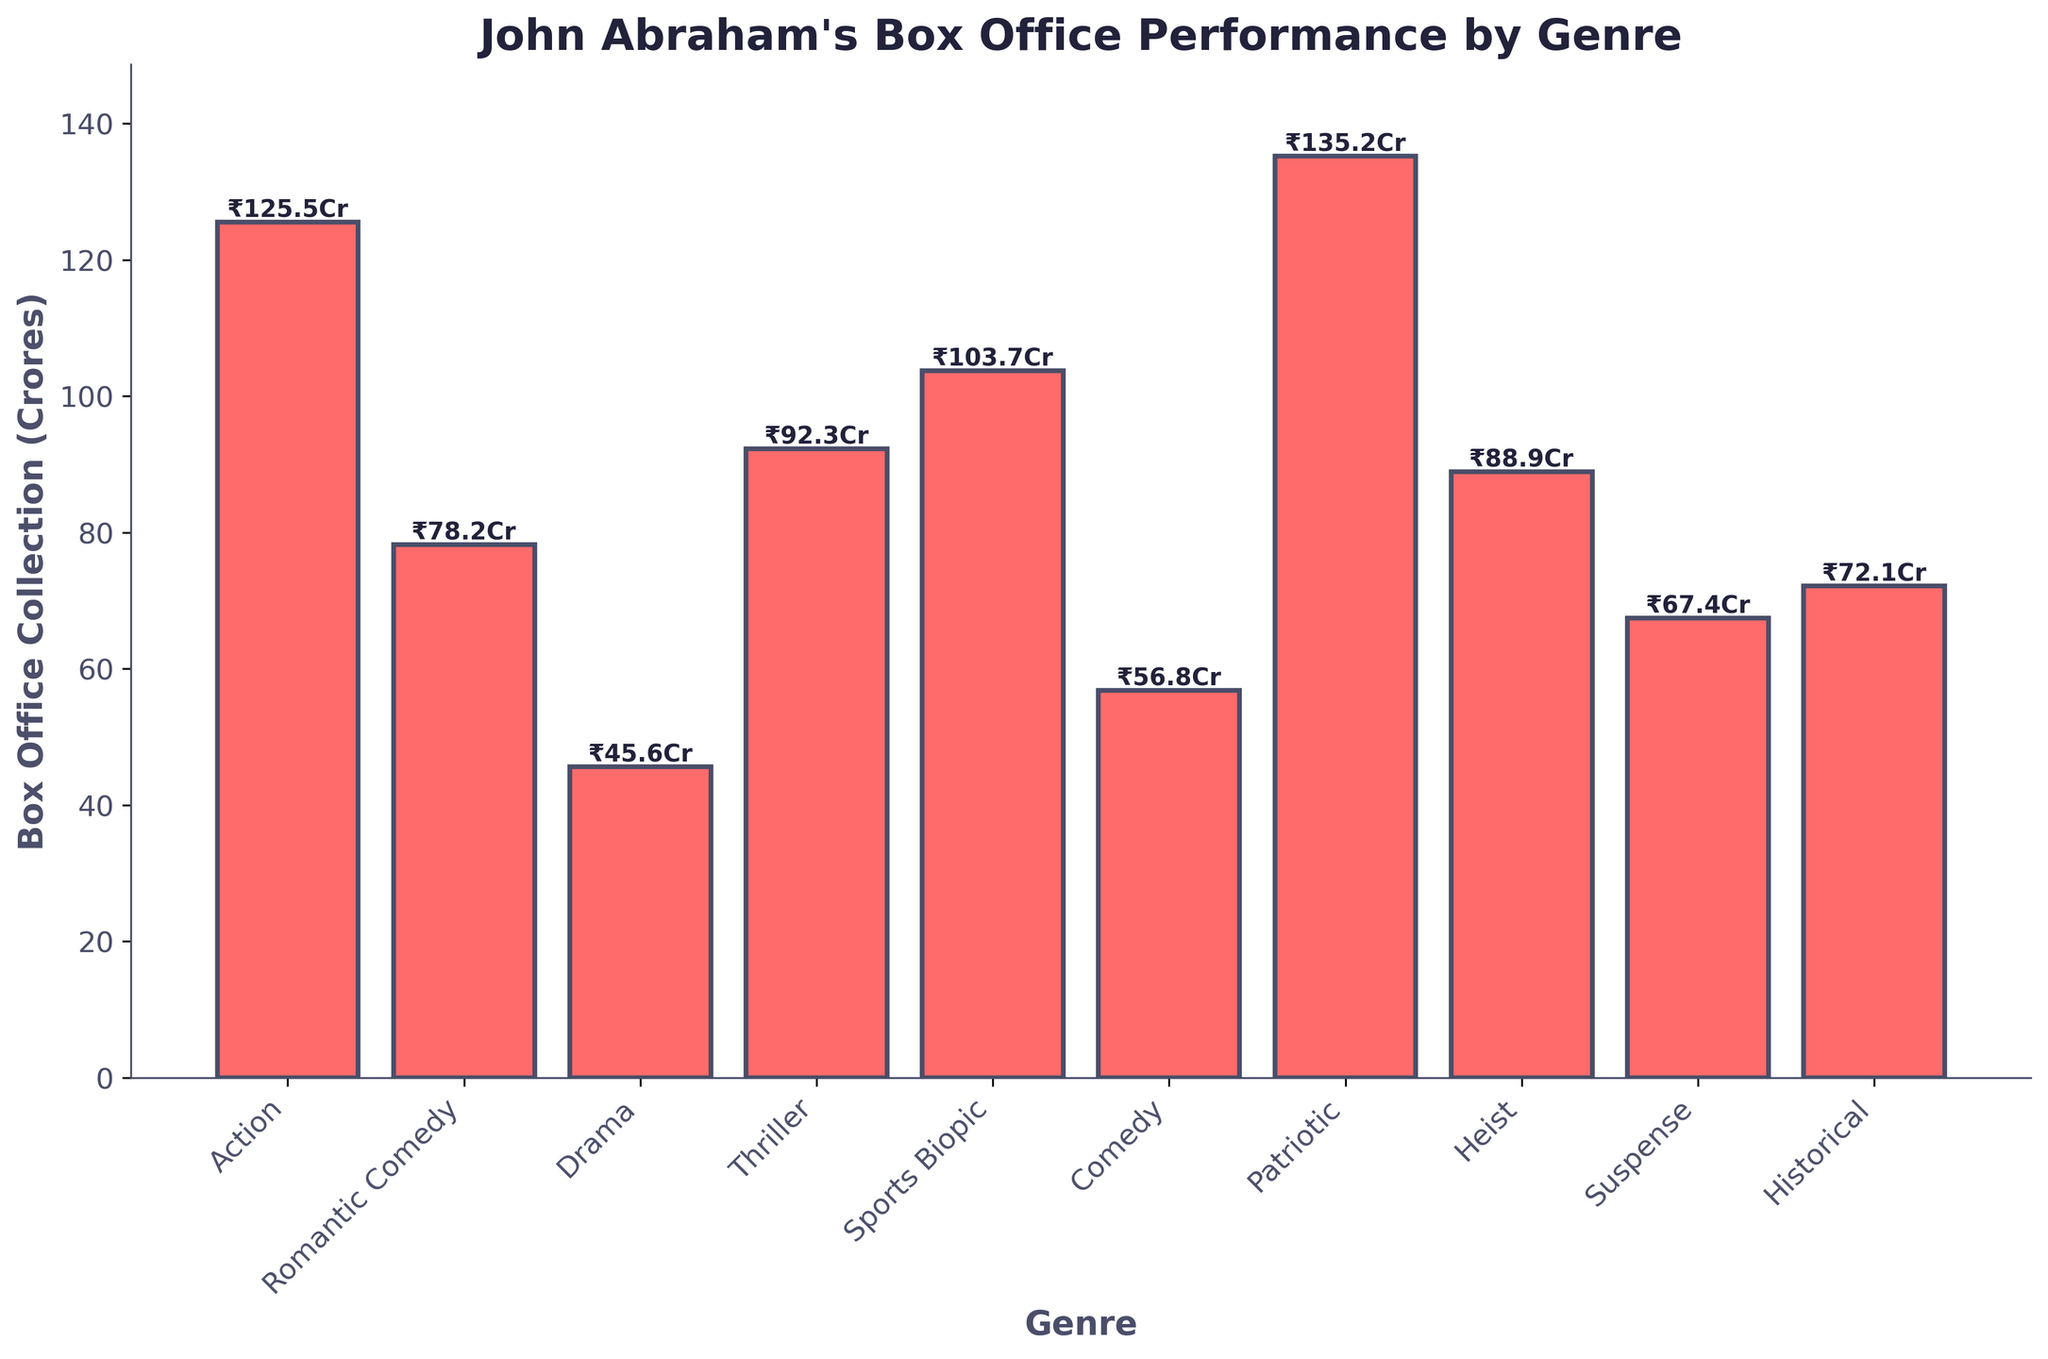Which genre has the highest box office collection? Identify the tallest bar in the chart, which visually represents the genre with the highest collection. The tallest bar corresponds to the "Patriotic" genre.
Answer: Patriotic Which genre has the lowest box office collection? Identify the shortest bar in the chart. The shortest bar, and hence the genre with the lowest box office collection, corresponds to "Drama".
Answer: Drama What is the combined box office collection of Action and Thriller genres? Add the box office collections for Action (125.5 Crores) and Thriller (92.3 Crores): 125.5 + 92.3 = 217.8 Crores.
Answer: 217.8 Crores Which two genres have the closest box office collections, and what are their respective values? Compare the bars' heights and find the two that are closest. "Historical" at 72.1 Crores and "Romantic Comedy" at 78.2 Crores have close values.
Answer: Historical (72.1 Crores) and Romantic Comedy (78.2 Crores) What is the difference in box office collections between the genres with the highest and the lowest values? Subtract the collection of the lowest genre (Drama, 45.6 Crores) from the highest genre (Patriotic, 135.2 Crores): 135.2 - 45.6 = 89.6 Crores.
Answer: 89.6 Crores How many genres have box office collections greater than 100 Crores? Identify the bars that are taller than the 100 Crores mark. The genres are Action, Sports Biopic, and Patriotic, totaling 3 genres.
Answer: 3 What is the average box office collection of the Comedy and Heist genres? Calculate the average by adding the collections for Comedy (56.8 Crores) and Heist (88.9 Crores) and then dividing by 2: (56.8 + 88.9) / 2 = 72.85 Crores.
Answer: 72.85 Crores Which genres have collections between 50 Crores and 100 Crores? Identify the bars whose heights fall between the 50 Crores and 100 Crores marks. These genres are Romantic Comedy (78.2 Crores), Comedy (56.8 Crores), Suspense (67.4 Crores), and Heist (88.9 Crores).
Answer: Romantic Comedy, Comedy, Suspense, Heist What is the total box office collection of all genres combined? Sum all the individual box office collections to get the total: 125.5 + 78.2 + 45.6 + 92.3 + 103.7 + 56.8 + 135.2 + 88.9 + 67.4 + 72.1 = 865.7 Crores.
Answer: 865.7 Crores Which genre has the second highest box office collection, and what is its value? Identify the genre with the second tallest bar in the chart after the Patriotic genre. The second tallest bar corresponds to the Action genre with 125.5 Crores.
Answer: Action, 125.5 Crores 